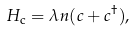<formula> <loc_0><loc_0><loc_500><loc_500>H _ { \text {c} } = \lambda n ( c + c ^ { \dagger } ) ,</formula> 